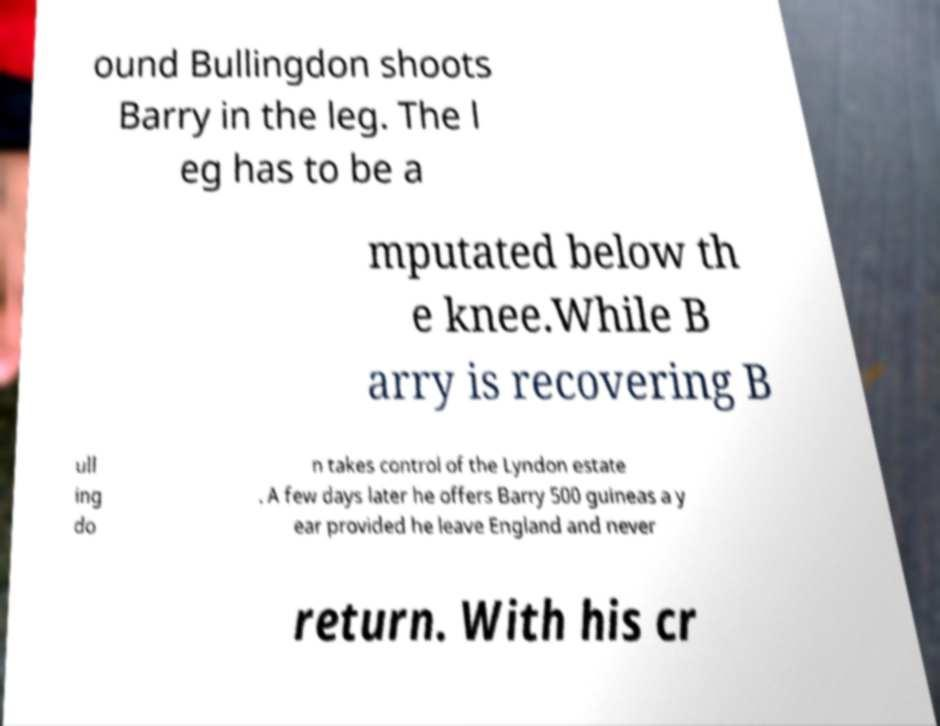Please identify and transcribe the text found in this image. ound Bullingdon shoots Barry in the leg. The l eg has to be a mputated below th e knee.While B arry is recovering B ull ing do n takes control of the Lyndon estate . A few days later he offers Barry 500 guineas a y ear provided he leave England and never return. With his cr 